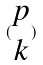Convert formula to latex. <formula><loc_0><loc_0><loc_500><loc_500>( \begin{matrix} p \\ k \end{matrix} )</formula> 